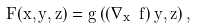Convert formula to latex. <formula><loc_0><loc_0><loc_500><loc_500>F ( x , y , z ) = g \left ( \left ( \nabla _ { x } \ f \right ) y , z \right ) ,</formula> 